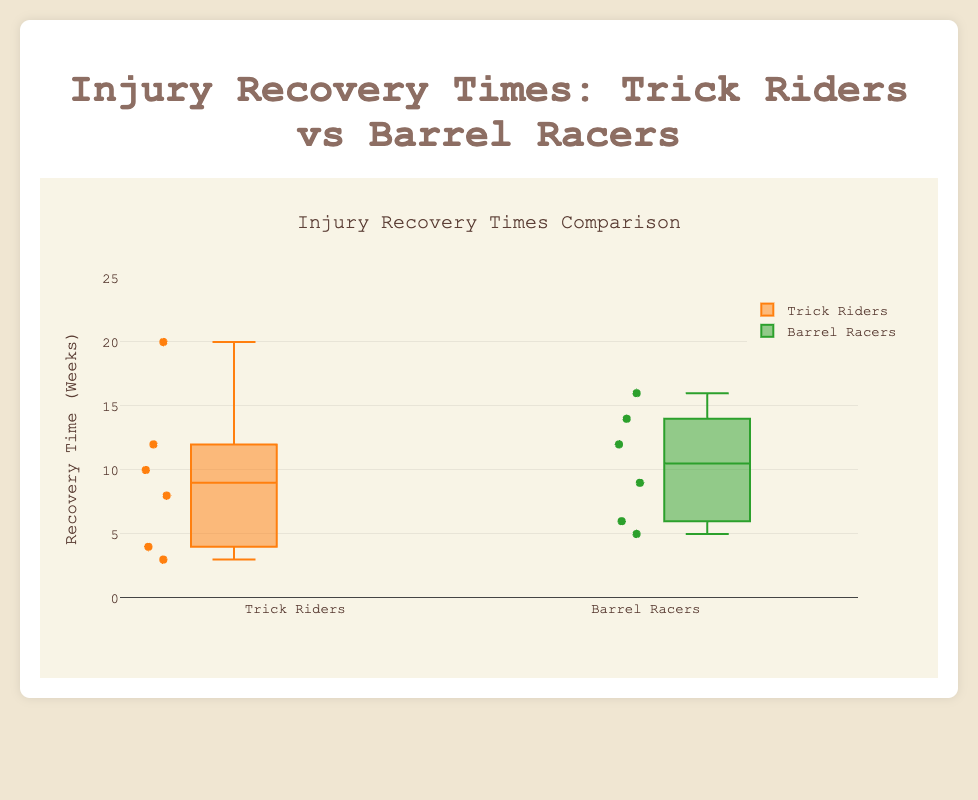What's the title of the figure? The title is clearly indicated at the top of the figure. It tells us what the figure is about directly.
Answer: Injury Recovery Times: Trick Riders vs Barrel Racers What is measured on the y-axis? The y-axis title labels the measurement. It shows the units used for measurement in the study.
Answer: Recovery Time (Weeks) What is the range of recovery times shown in the plot? The y-axis labels provide the range of values shown. By looking at these labels, we can determine the minimum and maximum values.
Answer: 0 to 25 weeks Which group has the longer median recovery time? The median recovery time is indicated by the line inside each box. By comparing these lines between the two groups, we can determine which group has the longer median recovery time.
Answer: Trick Riders Which outlier has the shortest recovery time? Outliers are indicated by points outside the boxes. By comparing the recovery times of these outliers, we can identify the shortest one.
Answer: Lily Anderson (3 weeks) What is the interquartile range (IQR) for Barrel Racers? The IQR is the range between the first quartile (Q1) and the third quartile (Q3). It is the length of the box in the boxplot for Barrel Racers. By subtracting Q1 from Q3, we get the IQR.
Answer: 9 - 6 = 3 weeks What is the difference between the maximum recovery times for Trick Riders and Barrel Racers? The maximum recovery time is indicated by the topmost point within the whisker of each boxplot. By comparing these points between the two groups, we can determine the difference.
Answer: 20 weeks (Trick Riders) - 16 weeks (Barrel Racers) = 4 weeks Which group has a greater spread in recovery times? The spread is indicated by the length of the whiskers in a boxplot. By comparing the lengths of the whiskers in both groups, we can determine which group has a greater spread in recovery times.
Answer: Trick Riders What's the shortest recovery time for Barrel Racers and who does it belong to? The shortest recovery time is the lowest point within the whisker of Barrel Racers. The data gives us the corresponding name for this value.
Answer: Olivia Brown (5 weeks) What is the median recovery time for Barrel Racers? The median recovery time is represented by the line inside the box for Barrel Racers.
Answer: 9 weeks 